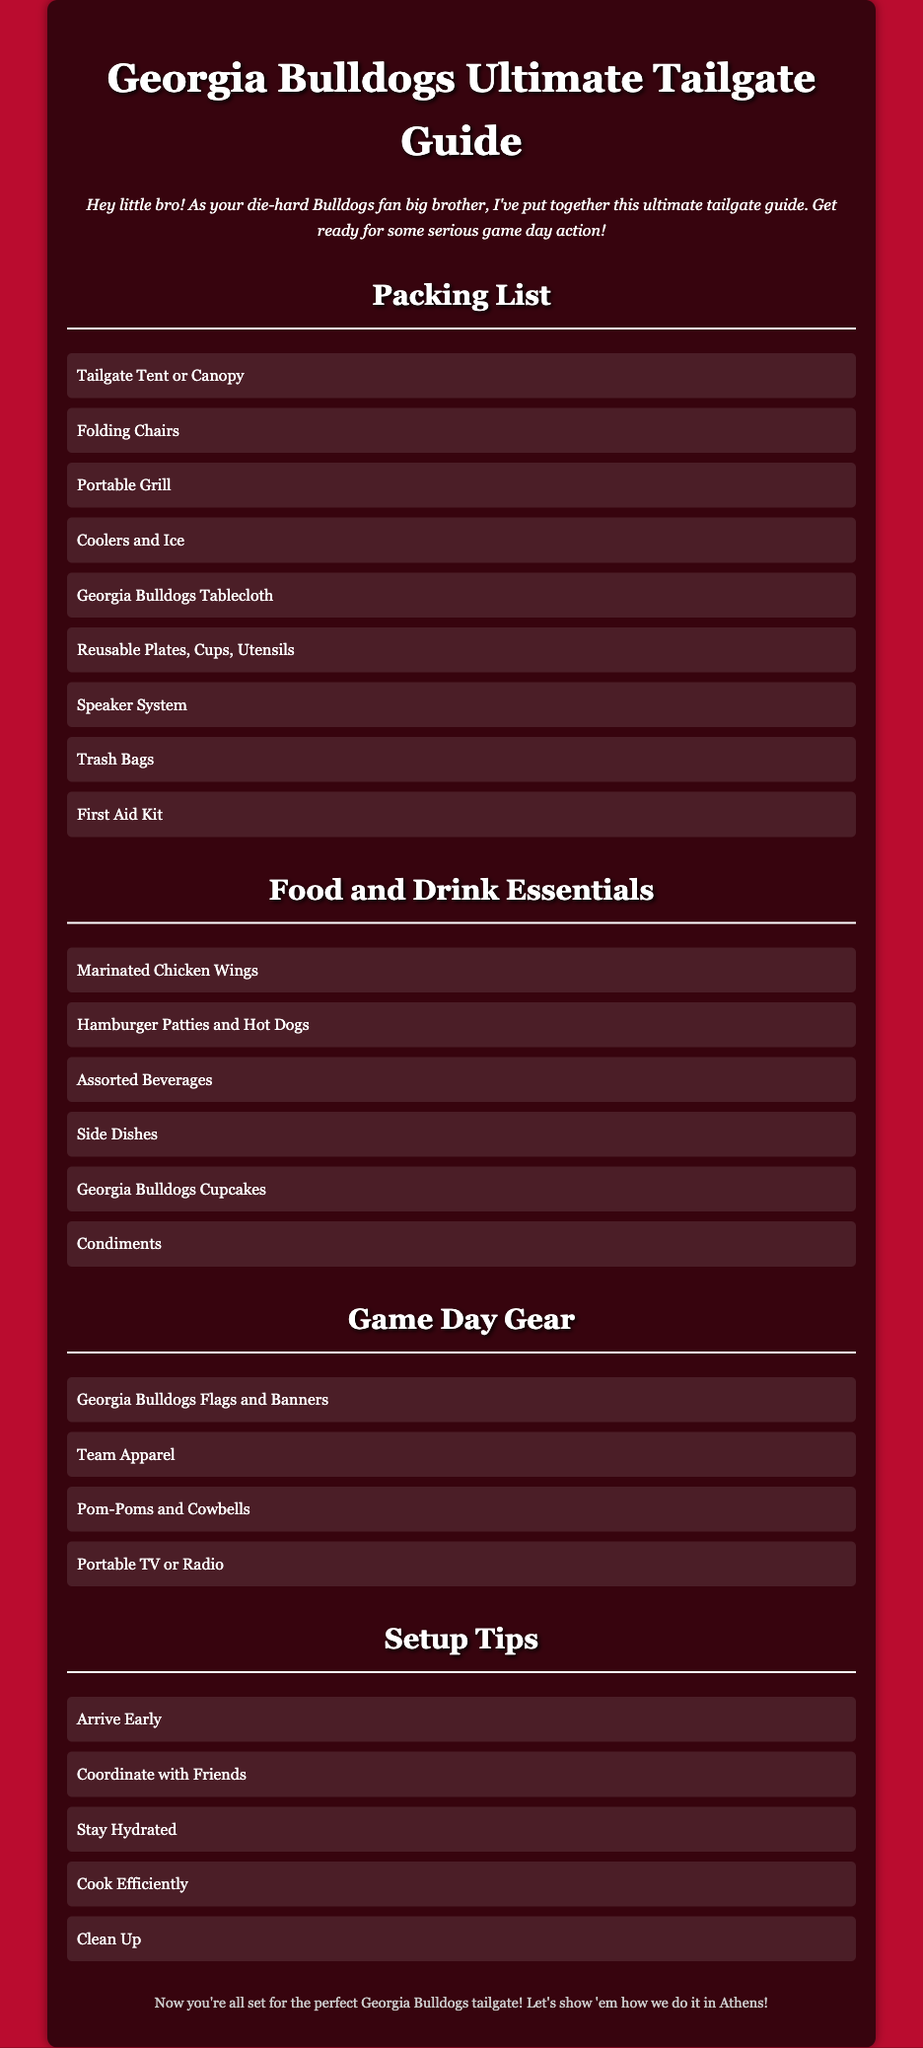What items are included in the packing list? The packing list includes various essential items needed for the tailgate.
Answer: Tailgate Tent or Canopy, Folding Chairs, Portable Grill, Coolers and Ice, Georgia Bulldogs Tablecloth, Reusable Plates, Cups, Utensils, Speaker System, Trash Bags, First Aid Kit What food item is listed as a must-have for the tailgate? The document specifies essential food items that should be prepared for the tailgate.
Answer: Marinated Chicken Wings How many types of game day gear are mentioned? The gear section lists specific items that are important for showing team spirit during the game.
Answer: Four What is the first setup tip mentioned? The setup tips provide advice for organizing a successful tailgate experience.
Answer: Arrive Early Which dessert item is featured in the food essentials? The document includes food items that are particularly themed for the Georgia Bulldogs.
Answer: Georgia Bulldogs Cupcakes What is the color theme of the document? The color theme refers to the main colors used in the design of the document to represent the team.
Answer: Red and Black How should you efficiently manage your food during the tailgate? The reasoning requires synthesis on how to handle food preparation and management at the event.
Answer: Cook Efficiently What should you do to stay clean during the tailgate? This question pertains to the importance of cleanliness during the event for a good experience.
Answer: Clean Up 